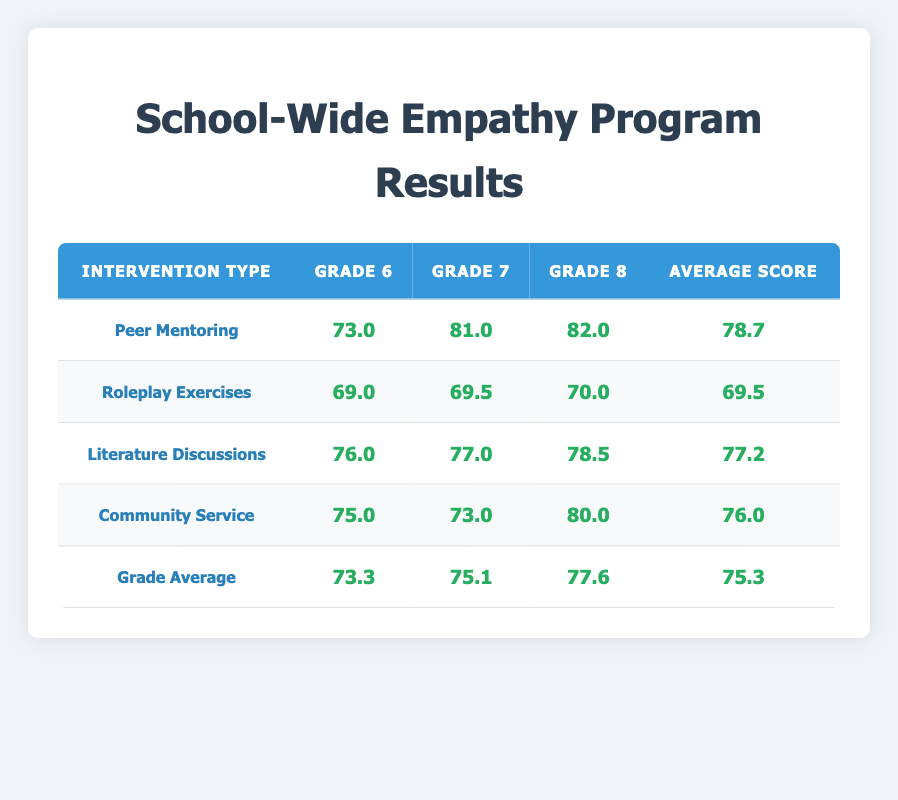What is the empathy score for students in Grade 8 participating in Peer Mentoring? The table shows that the empathy score for Grade 8 students in Peer Mentoring is 82.0.
Answer: 82.0 What is the average empathy score for Community Service across all grades? To find the average empathy score for Community Service, we sum the empathy scores: 75.0 (Grade 6) + 73.0 (Grade 7) + 80.0 (Grade 8) = 228.0. Then, we divide by the number of grades (3), yielding 228.0 / 3 = 76.0.
Answer: 76.0 Did any Grade 6 students have an empathy score below 70? The empathy scores for Grade 6 are 72.0, 75.0, 76.0, and 69.0. 69.0 is below 70, confirming that there is at least one student with a score below 70.
Answer: Yes Which intervention type has the highest average empathy score? To determine the highest average empathy score, we find the average of each intervention type: Peer Mentoring: 78.7, Roleplay Exercises: 69.5, Literature Discussions: 77.2, Community Service: 76.0. The highest average is for Peer Mentoring (78.7).
Answer: Peer Mentoring What is the combined empathy score for Literature Discussions in Grade 7 and Grade 8? The empathy scores for Literature Discussions are 77.0 (Grade 7) and 78.5 (Grade 8). We sum them: 77.0 + 78.5 = 155.5.
Answer: 155.5 How many students participated in Roleplay Exercises across all grades? The table shows that 2 students from Grade 6 and 2 students from Grade 7 and 1 student from Grade 8 participated in Roleplay Exercises. Therefore, the total is 2 + 2 + 1 = 5 students.
Answer: 5 students 